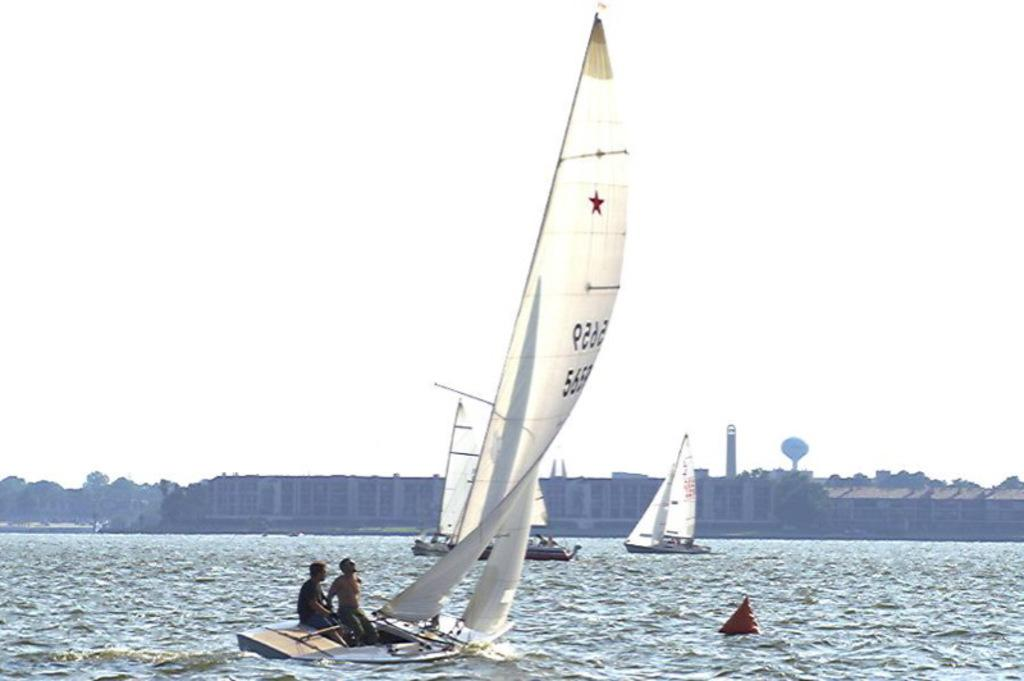What is happening on the water in the image? There are boats on the water in the image. Can you describe the people in the boats? Two persons are sitting in one of the boats. What can be seen in the background of the image? There are buildings, trees, and the sky visible in the background of the image. What type of table is being used by the persons in the boat? There is no table present in the image; the persons are sitting in a boat on the water. Can you describe the cart that is being pulled by the clouds in the image? There are no clouds or carts present in the image; it features boats on the water with people in them and a background of buildings, trees, and the sky. 